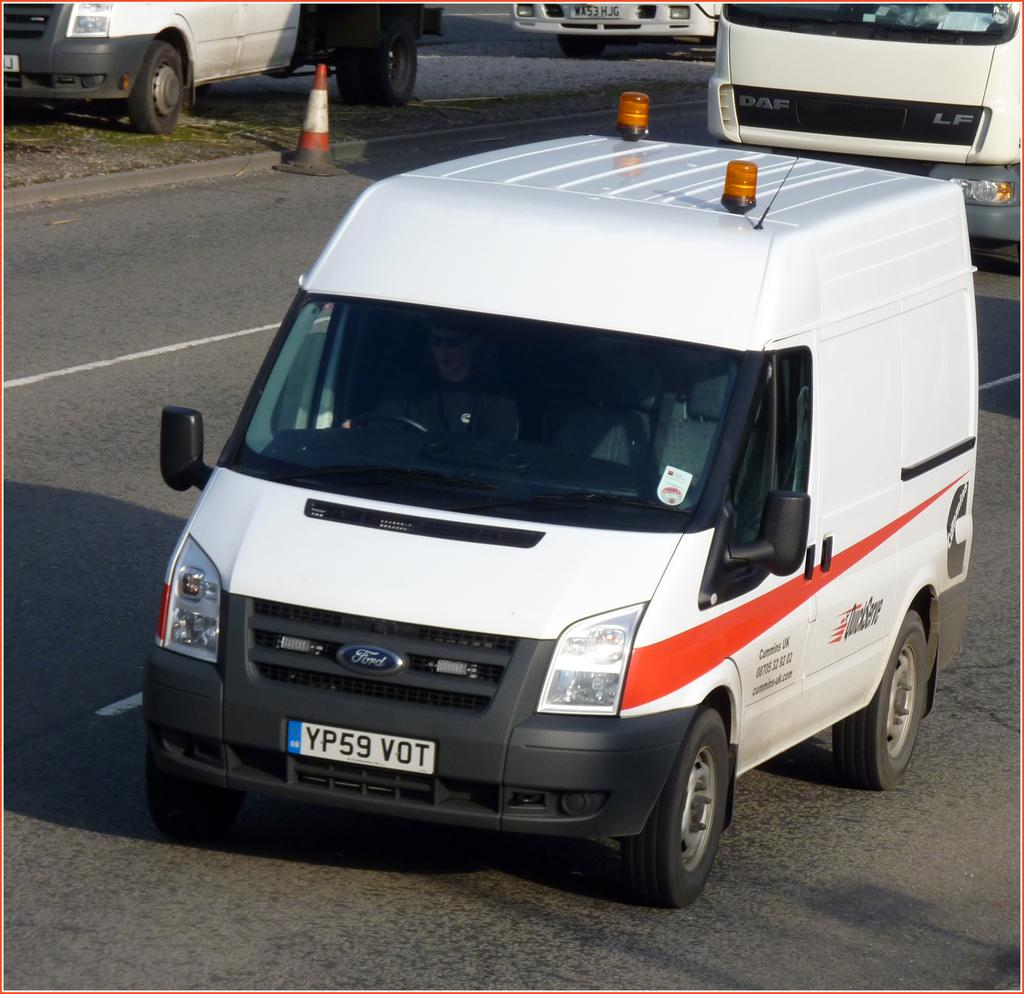<image>
Create a compact narrative representing the image presented. A Ford van with QuickServe on the side and plate number YP59 VOT 